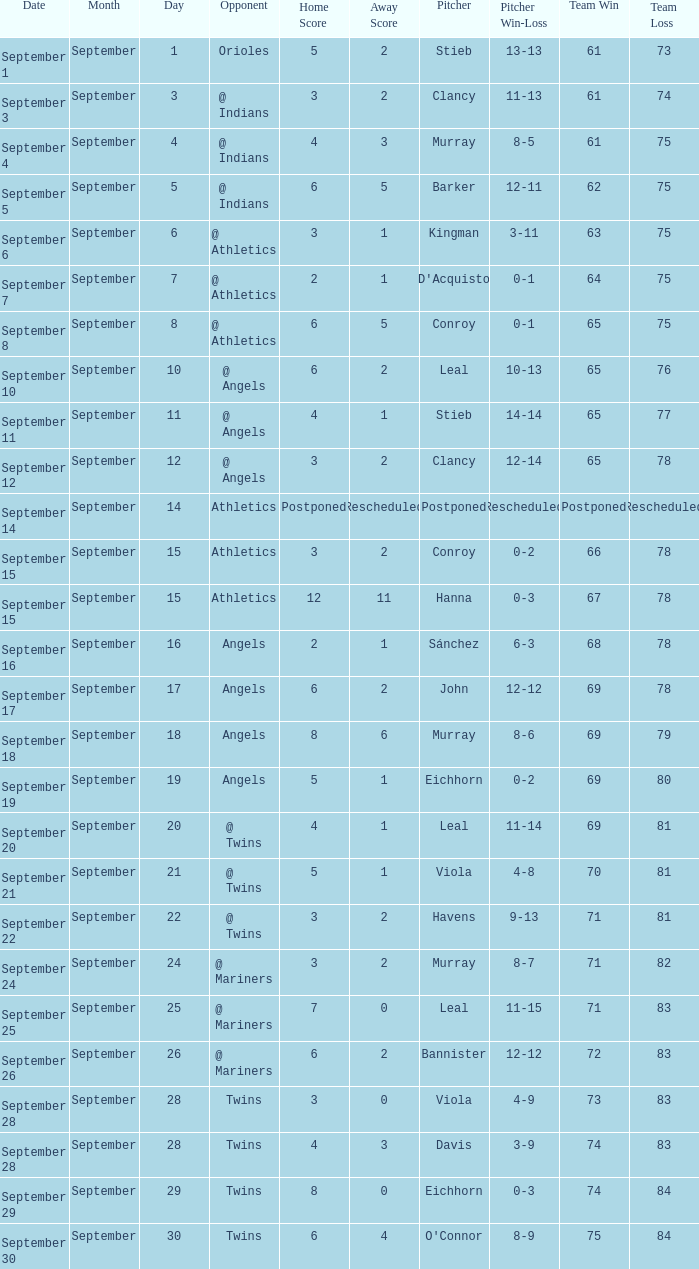Parse the table in full. {'header': ['Date', 'Month', 'Day', 'Opponent', 'Home Score', 'Away Score', 'Pitcher', 'Pitcher Win-Loss', 'Team Win', 'Team Loss'], 'rows': [['September 1', 'September', '1', 'Orioles', '5', '2', 'Stieb', '13-13', '61', '73'], ['September 3', 'September', '3', '@ Indians', '3', '2', 'Clancy', '11-13', '61', '74'], ['September 4', 'September', '4', '@ Indians', '4', '3', 'Murray', '8-5', '61', '75'], ['September 5', 'September', '5', '@ Indians', '6', '5', 'Barker', '12-11', '62', '75'], ['September 6', 'September', '6', '@ Athletics', '3', '1', 'Kingman', '3-11', '63', '75'], ['September 7', 'September', '7', '@ Athletics', '2', '1', "D'Acquisto", '0-1', '64', '75'], ['September 8', 'September', '8', '@ Athletics', '6', '5', 'Conroy', '0-1', '65', '75'], ['September 10', 'September', '10', '@ Angels', '6', '2', 'Leal', '10-13', '65', '76'], ['September 11', 'September', '11', '@ Angels', '4', '1', 'Stieb', '14-14', '65', '77'], ['September 12', 'September', '12', '@ Angels', '3', '2', 'Clancy', '12-14', '65', '78'], ['September 14', 'September', '14', 'Athletics', 'Postponed', 'Rescheduled', 'Postponed', 'Rescheduled', 'Postponed', 'Rescheduled'], ['September 15', 'September', '15', 'Athletics', '3', '2', 'Conroy', '0-2', '66', '78'], ['September 15', 'September', '15', 'Athletics', '12', '11', 'Hanna', '0-3', '67', '78'], ['September 16', 'September', '16', 'Angels', '2', '1', 'Sánchez', '6-3', '68', '78'], ['September 17', 'September', '17', 'Angels', '6', '2', 'John', '12-12', '69', '78'], ['September 18', 'September', '18', 'Angels', '8', '6', 'Murray', '8-6', '69', '79'], ['September 19', 'September', '19', 'Angels', '5', '1', 'Eichhorn', '0-2', '69', '80'], ['September 20', 'September', '20', '@ Twins', '4', '1', 'Leal', '11-14', '69', '81'], ['September 21', 'September', '21', '@ Twins', '5', '1', 'Viola', '4-8', '70', '81'], ['September 22', 'September', '22', '@ Twins', '3', '2', 'Havens', '9-13', '71', '81'], ['September 24', 'September', '24', '@ Mariners', '3', '2', 'Murray', '8-7', '71', '82'], ['September 25', 'September', '25', '@ Mariners', '7', '0', 'Leal', '11-15', '71', '83'], ['September 26', 'September', '26', '@ Mariners', '6', '2', 'Bannister', '12-12', '72', '83'], ['September 28', 'September', '28', 'Twins', '3', '0', 'Viola', '4-9', '73', '83'], ['September 28', 'September', '28', 'Twins', '4', '3', 'Davis', '3-9', '74', '83'], ['September 29', 'September', '29', 'Twins', '8', '0', 'Eichhorn', '0-3', '74', '84'], ['September 30', 'September', '30', 'Twins', '6', '4', "O'Connor", '8-9', '75', '84']]} Identify the losing count in a 71-81 record. Havens (9-13). 